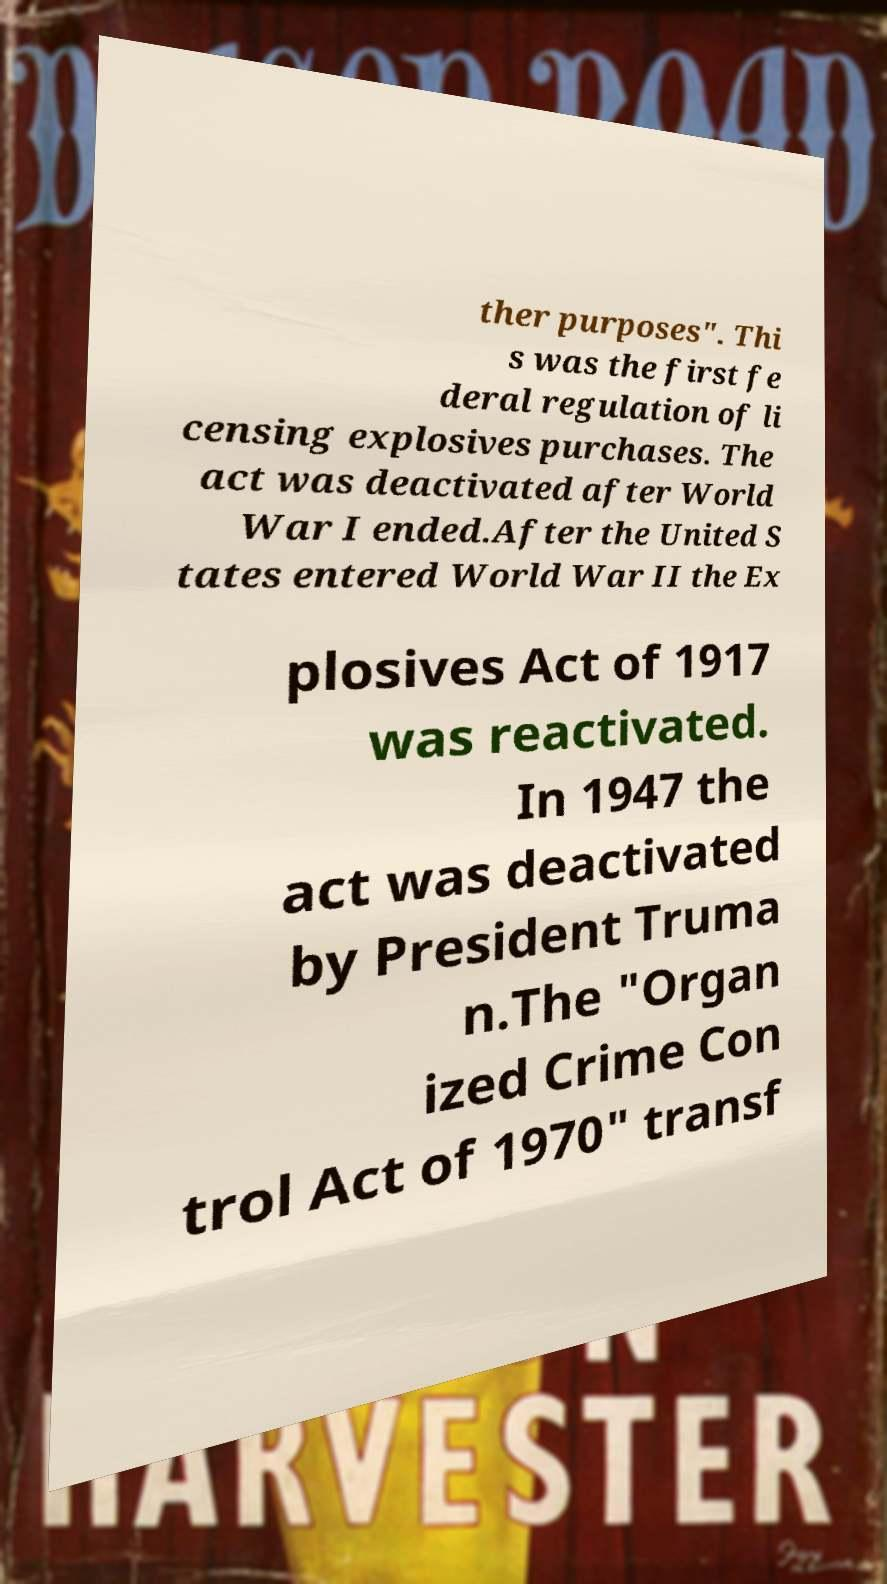Please read and relay the text visible in this image. What does it say? ther purposes". Thi s was the first fe deral regulation of li censing explosives purchases. The act was deactivated after World War I ended.After the United S tates entered World War II the Ex plosives Act of 1917 was reactivated. In 1947 the act was deactivated by President Truma n.The "Organ ized Crime Con trol Act of 1970" transf 